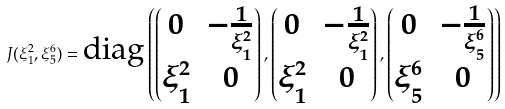Convert formula to latex. <formula><loc_0><loc_0><loc_500><loc_500>J ( { \xi ^ { 2 } _ { 1 } } , { \xi ^ { 6 } _ { 5 } } ) = \text {diag} \left ( \begin{pmatrix} 0 & - \frac { 1 } { \xi ^ { 2 } _ { 1 } } \\ { \xi ^ { 2 } _ { 1 } } & 0 \end{pmatrix} , \begin{pmatrix} 0 & - \frac { 1 } { \xi ^ { 2 } _ { 1 } } \\ { \xi ^ { 2 } _ { 1 } } & 0 \end{pmatrix} , \begin{pmatrix} 0 & - \frac { 1 } { \xi ^ { 6 } _ { 5 } } \\ { \xi ^ { 6 } _ { 5 } } & 0 \end{pmatrix} \right )</formula> 